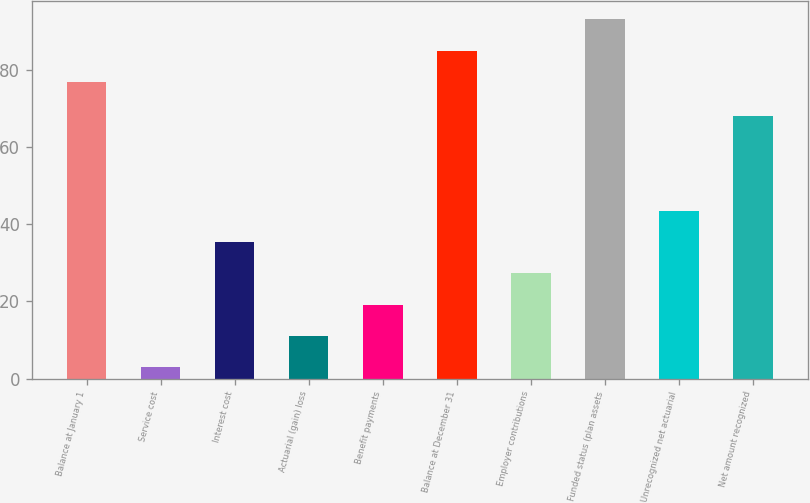Convert chart. <chart><loc_0><loc_0><loc_500><loc_500><bar_chart><fcel>Balance at January 1<fcel>Service cost<fcel>Interest cost<fcel>Actuarial (gain) loss<fcel>Benefit payments<fcel>Balance at December 31<fcel>Employer contributions<fcel>Funded status (plan assets<fcel>Unrecognized net actuarial<fcel>Net amount recognized<nl><fcel>77<fcel>3<fcel>35.4<fcel>11.1<fcel>19.2<fcel>85.1<fcel>27.3<fcel>93.2<fcel>43.5<fcel>68<nl></chart> 